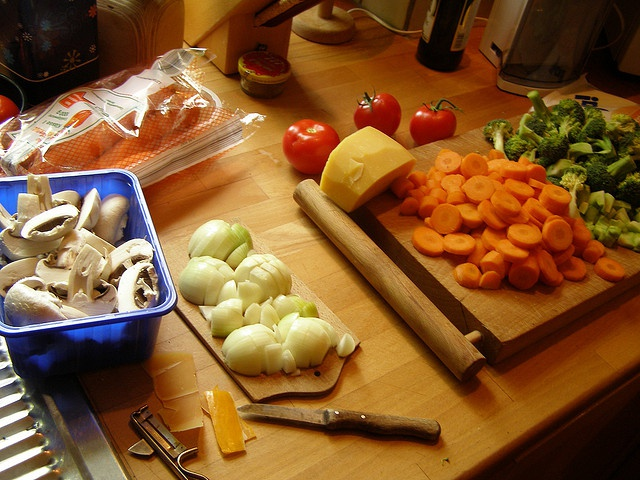Describe the objects in this image and their specific colors. I can see dining table in black, brown, maroon, and tan tones, bowl in black, ivory, tan, and navy tones, dining table in black, olive, orange, and maroon tones, carrot in black, red, and maroon tones, and knife in black, olive, and maroon tones in this image. 